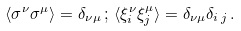Convert formula to latex. <formula><loc_0><loc_0><loc_500><loc_500>\langle \sigma ^ { \nu } \sigma ^ { \mu } \rangle = \delta _ { \nu \mu } \, ; \, \langle \xi ^ { \nu } _ { i } \xi ^ { \mu } _ { j } \rangle = \delta _ { \nu \mu } \delta _ { i \, j } \, .</formula> 